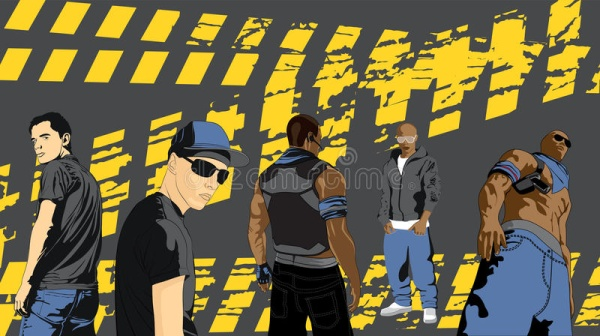Imagine this image is a scene from a movie poster. What genre could the movie be and what would the title be? The image suggests a genre of action-adventure with a hint of mystery. The movie could be titled 'Urban Warriors: The Brotherhood'. The plot could revolve around these five characters coming together to protect their city from looming threats, using their distinct skills and unwavering brotherhood to conquer obstacles and preserve peace. 